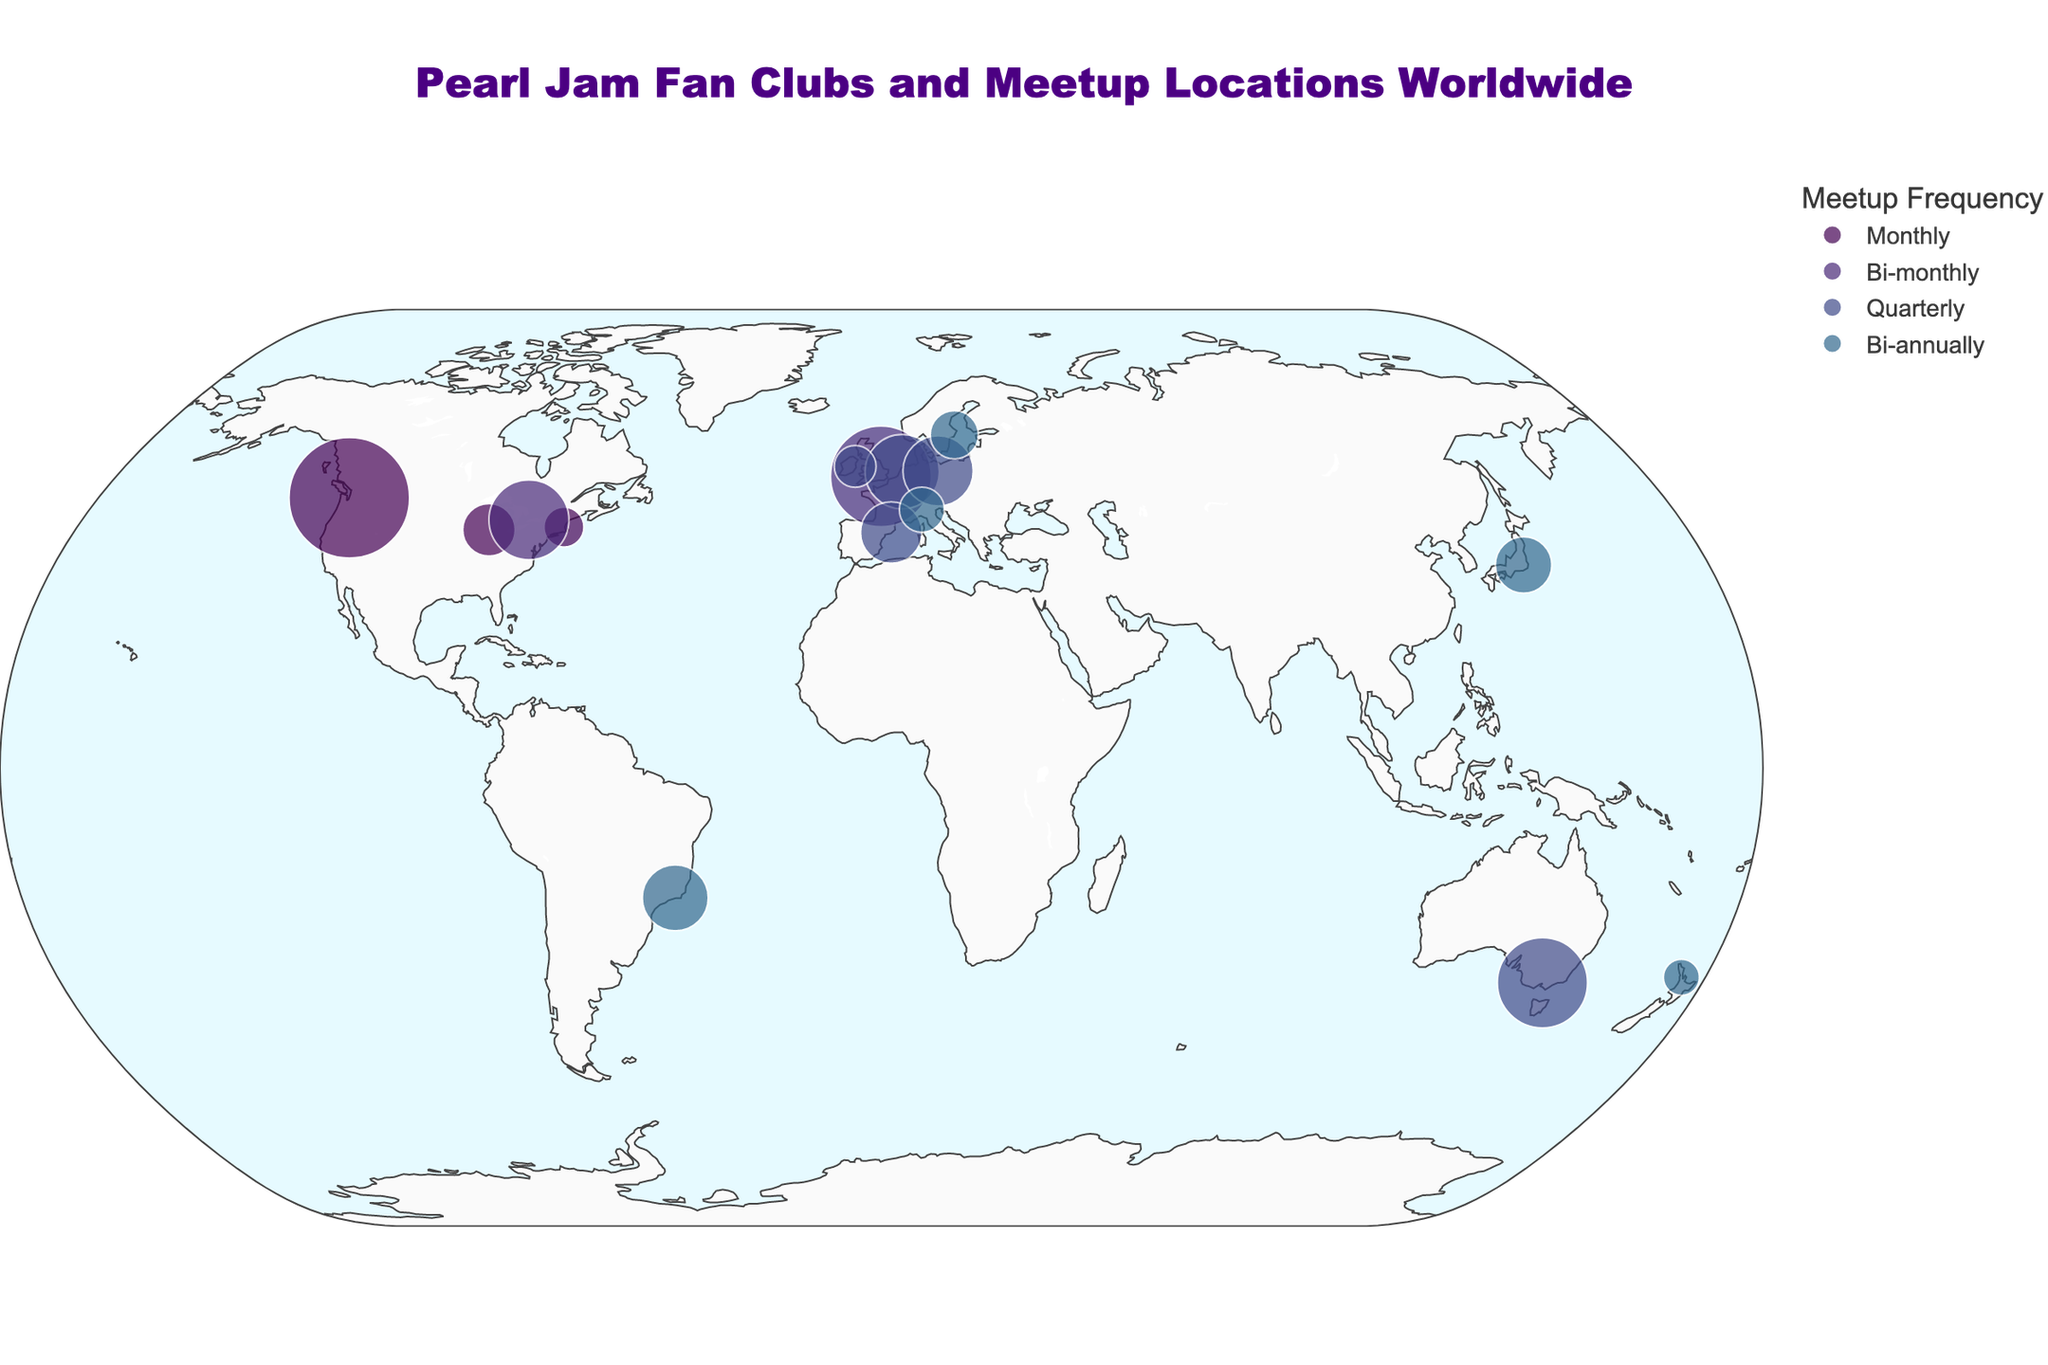Which city has the largest number of Pearl Jam fan club members? The figure shows the size of the circles proportional to the number of fan club members. The largest circle is over Seattle, USA.
Answer: Seattle Which cities have a meetup frequency of "Bi-annually"? From the color bar, we can match the color representing "Bi-annually". The cities with this color are Rio de Janeiro, Tokyo, Stockholm, Milan, and Auckland.
Answer: Rio de Janeiro, Tokyo, Stockholm, Milan, Auckland What is the title of the plot? The plot has a title at the top center which reads "Pearl Jam Fan Clubs and Meetup Locations Worldwide".
Answer: Pearl Jam Fan Clubs and Meetup Locations Worldwide How many cities are represented in Europe? Count the European cities shown on the map. These are London, Amsterdam, Berlin, Barcelona, Dublin, Milan, and Stockholm.
Answer: 7 Which city has more fan club members: Tokyo or Dublin? From the size of the circles, we can see that the circle over Tokyo is larger than the one over Dublin. The data says Tokyo has 1100 members whereas Dublin has 600 members.
Answer: Tokyo Which meetup frequency has the fewest cities associated with it? Refer to the color bar and map. The least represented frequency is "Monthly" with cities being Seattle, Chicago, and Boston.
Answer: Monthly Comparing the largest and smallest fan clubs, what is the difference in the number of members? The largest fan club is in Seattle with 5000 members, and the smallest is in Auckland with 450 members. The difference is 5000 - 450 = 4550.
Answer: 4550 What continents have cities with fan clubs based on the plot? Observing the locations, the continents with fan clubs are North America, Europe, South America, Asia, and Oceania.
Answer: North America, Europe, South America, Asia, Oceania Which two cities in North America have the closest meetup frequencies? Toronto and Boston both have a meetup frequency of "Bi-monthly".
Answer: Toronto and Boston What is the relationship between city location and number of fan club members? Visually inspect the map for any correlation between the city’s geographical location and the size of the circles representing fan club members. Generally, cities in North America and Europe show larger memberships.
Answer: North American and European cities tend to have more members 